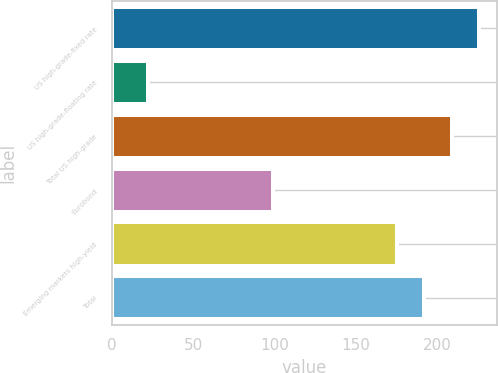Convert chart to OTSL. <chart><loc_0><loc_0><loc_500><loc_500><bar_chart><fcel>US high-grade-fixed rate<fcel>US high-grade-floating rate<fcel>Total US high-grade<fcel>Eurobond<fcel>Emerging markets high-yield<fcel>Total<nl><fcel>225.4<fcel>22<fcel>208.6<fcel>99<fcel>175<fcel>191.8<nl></chart> 